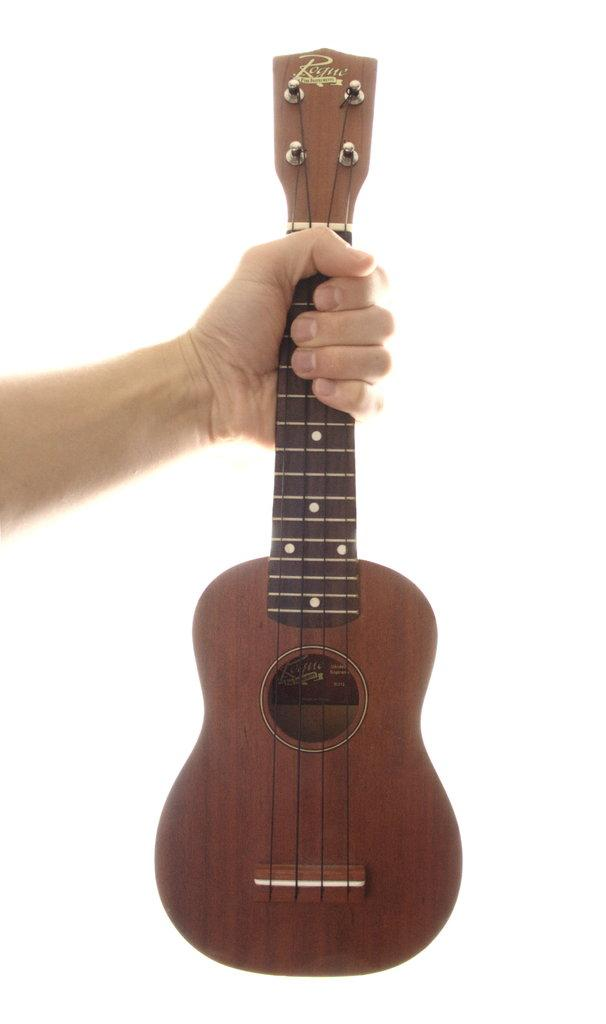What is the main subject of the image? There is a person in the image. What is the person holding in the image? The person is holding a guitar. Can you describe the guitar's appearance? The guitar is brown in color. What type of yarn is the person using to fight in the image? There is no yarn or fighting depicted in the image; the person is simply holding a brown guitar. 